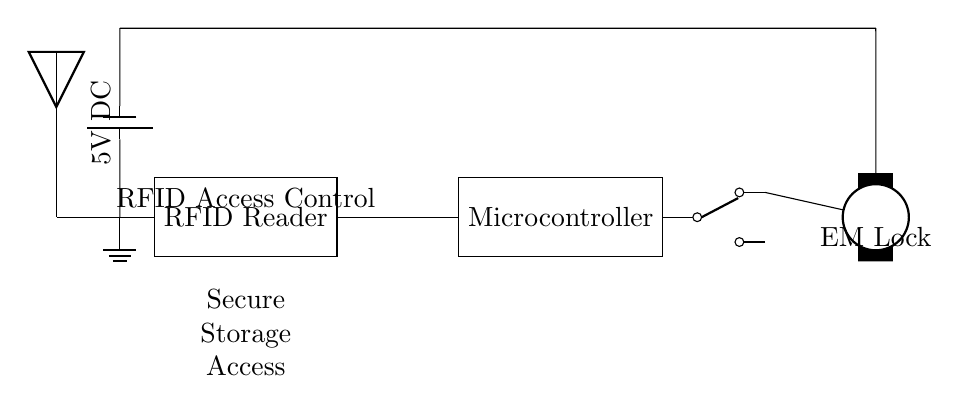What component is used for reading RFID tags? The circuit diagram shows an RFID Reader as the component responsible for reading RFID tags. It is typically located on the left side of the diagram labeled clearly.
Answer: RFID Reader What type of lock is depicted in the circuit? The diagram shows an electromagnetic lock, indicated by the label 'EM Lock' at the bottom right of the circuit. This type of lock uses electromagnetic force to secure access.
Answer: Electromagnetic Lock What is the power supply voltage in the circuit? A battery labeled as '5V DC' supplies the circuit with power, which can be seen at the top left corner of the diagram. This is the voltage value that powers the components.
Answer: 5V DC What is the role of the microcontroller in this circuit? The microcontroller acts as the central processing unit for the circuit, controlling the functions of the RFID Reader and the relay, ensuring access control functionality. Its role is indicated by its connection to both the RFID Reader and the relay.
Answer: Control functions How does the relay interact with the lock? The relay acts as a switch in the circuit, allowing the microcontroller to control the flow of current to the electromagnetic lock. When the microcontroller sends a signal through the relay, it completes the circuit to unlock the lock. The connection can be tracked through the lines from the microcontroller to the relay and from the relay to the lock.
Answer: Switch for unlocking What connects the RFID Reader and the microcontroller? The connection between the RFID Reader and the microcontroller is indicated by a direct line, showing that they are integrated within the circuit. It signifies that the microcontroller receives data from the RFID Reader.
Answer: Direct connection Where is the RFID antenna located? The RFID antenna is shown on the left side of the circuit diagram, next to the RFID Reader, indicating its position in relation to the reader as they work together to transmit and receive signals.
Answer: Left of the reader 